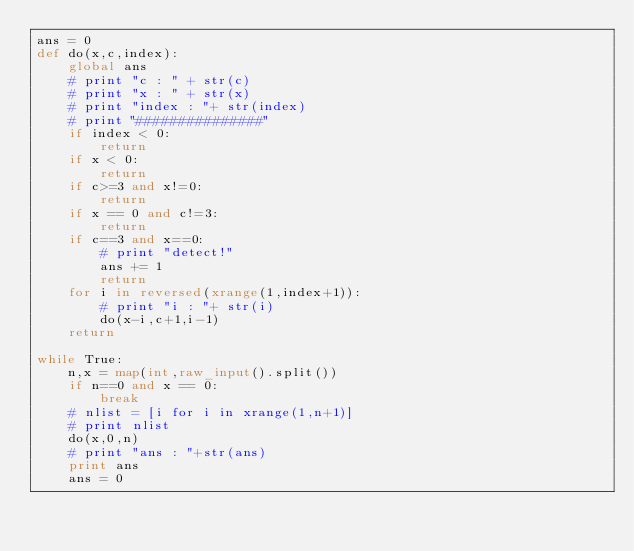Convert code to text. <code><loc_0><loc_0><loc_500><loc_500><_Python_>ans = 0
def do(x,c,index):
    global ans
    # print "c : " + str(c)
    # print "x : " + str(x)
    # print "index : "+ str(index)
    # print "###############"
    if index < 0:
        return
    if x < 0:
        return
    if c>=3 and x!=0:
        return
    if x == 0 and c!=3:
        return
    if c==3 and x==0:
        # print "detect!"
        ans += 1
        return
    for i in reversed(xrange(1,index+1)):
        # print "i : "+ str(i)
        do(x-i,c+1,i-1)
    return

while True:
    n,x = map(int,raw_input().split())
    if n==0 and x == 0:
        break
    # nlist = [i for i in xrange(1,n+1)]
    # print nlist
    do(x,0,n)
    # print "ans : "+str(ans)
    print ans
    ans = 0</code> 